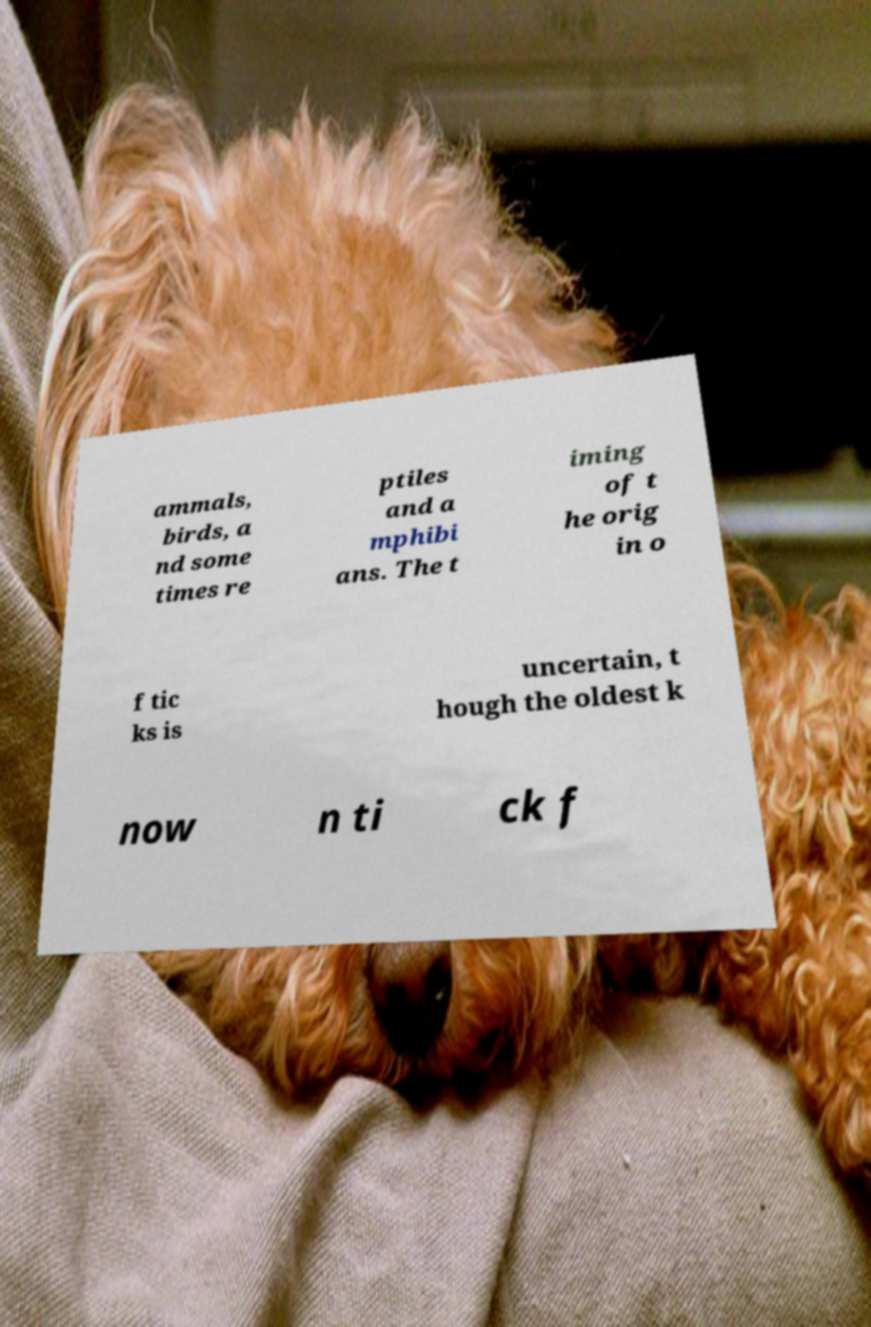Could you assist in decoding the text presented in this image and type it out clearly? ammals, birds, a nd some times re ptiles and a mphibi ans. The t iming of t he orig in o f tic ks is uncertain, t hough the oldest k now n ti ck f 